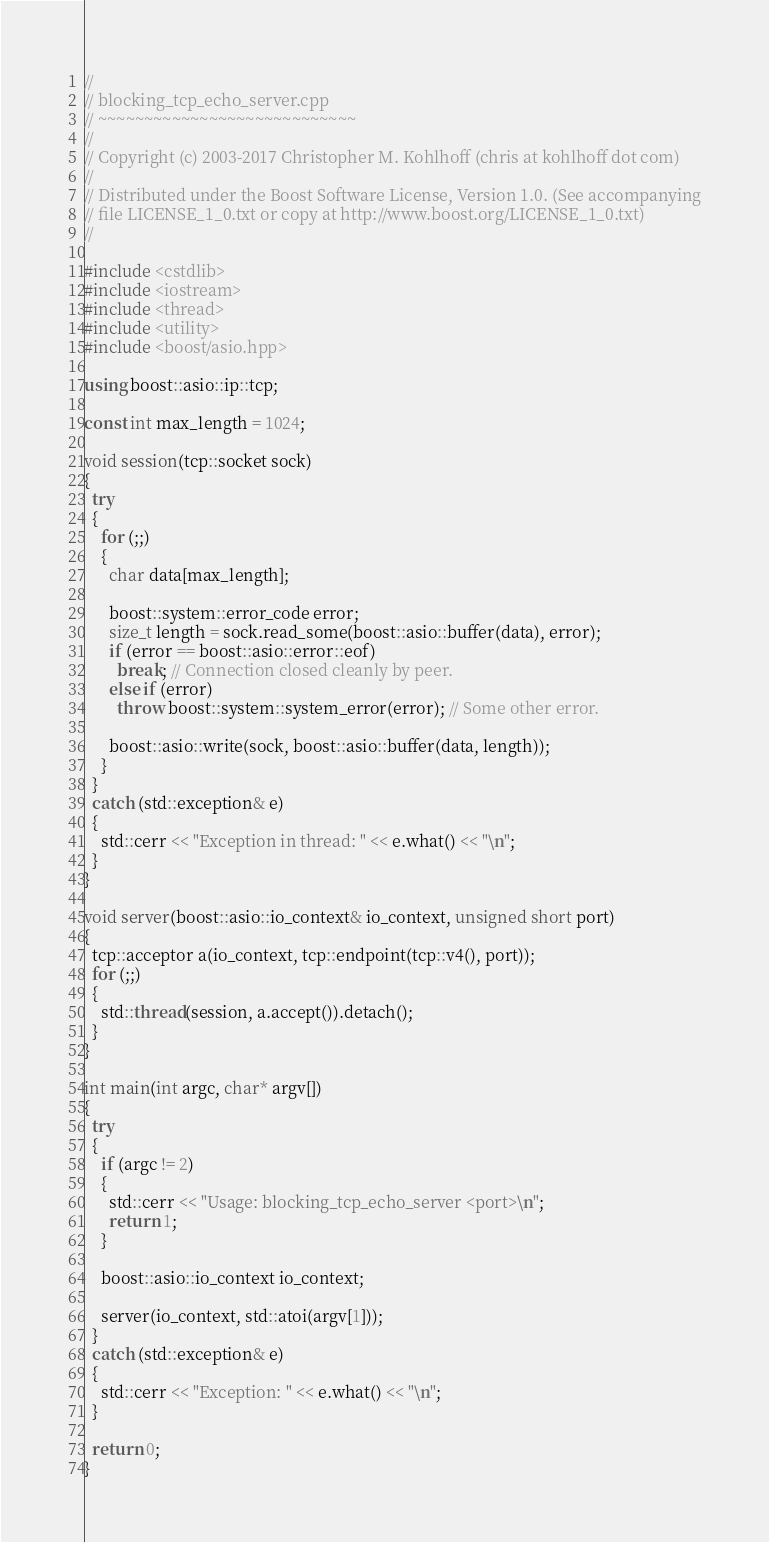Convert code to text. <code><loc_0><loc_0><loc_500><loc_500><_C++_>//
// blocking_tcp_echo_server.cpp
// ~~~~~~~~~~~~~~~~~~~~~~~~~~~~
//
// Copyright (c) 2003-2017 Christopher M. Kohlhoff (chris at kohlhoff dot com)
//
// Distributed under the Boost Software License, Version 1.0. (See accompanying
// file LICENSE_1_0.txt or copy at http://www.boost.org/LICENSE_1_0.txt)
//

#include <cstdlib>
#include <iostream>
#include <thread>
#include <utility>
#include <boost/asio.hpp>

using boost::asio::ip::tcp;

const int max_length = 1024;

void session(tcp::socket sock)
{
  try
  {
    for (;;)
    {
      char data[max_length];

      boost::system::error_code error;
      size_t length = sock.read_some(boost::asio::buffer(data), error);
      if (error == boost::asio::error::eof)
        break; // Connection closed cleanly by peer.
      else if (error)
        throw boost::system::system_error(error); // Some other error.

      boost::asio::write(sock, boost::asio::buffer(data, length));
    }
  }
  catch (std::exception& e)
  {
    std::cerr << "Exception in thread: " << e.what() << "\n";
  }
}

void server(boost::asio::io_context& io_context, unsigned short port)
{
  tcp::acceptor a(io_context, tcp::endpoint(tcp::v4(), port));
  for (;;)
  {
    std::thread(session, a.accept()).detach();
  }
}

int main(int argc, char* argv[])
{
  try
  {
    if (argc != 2)
    {
      std::cerr << "Usage: blocking_tcp_echo_server <port>\n";
      return 1;
    }

    boost::asio::io_context io_context;

    server(io_context, std::atoi(argv[1]));
  }
  catch (std::exception& e)
  {
    std::cerr << "Exception: " << e.what() << "\n";
  }

  return 0;
}
</code> 